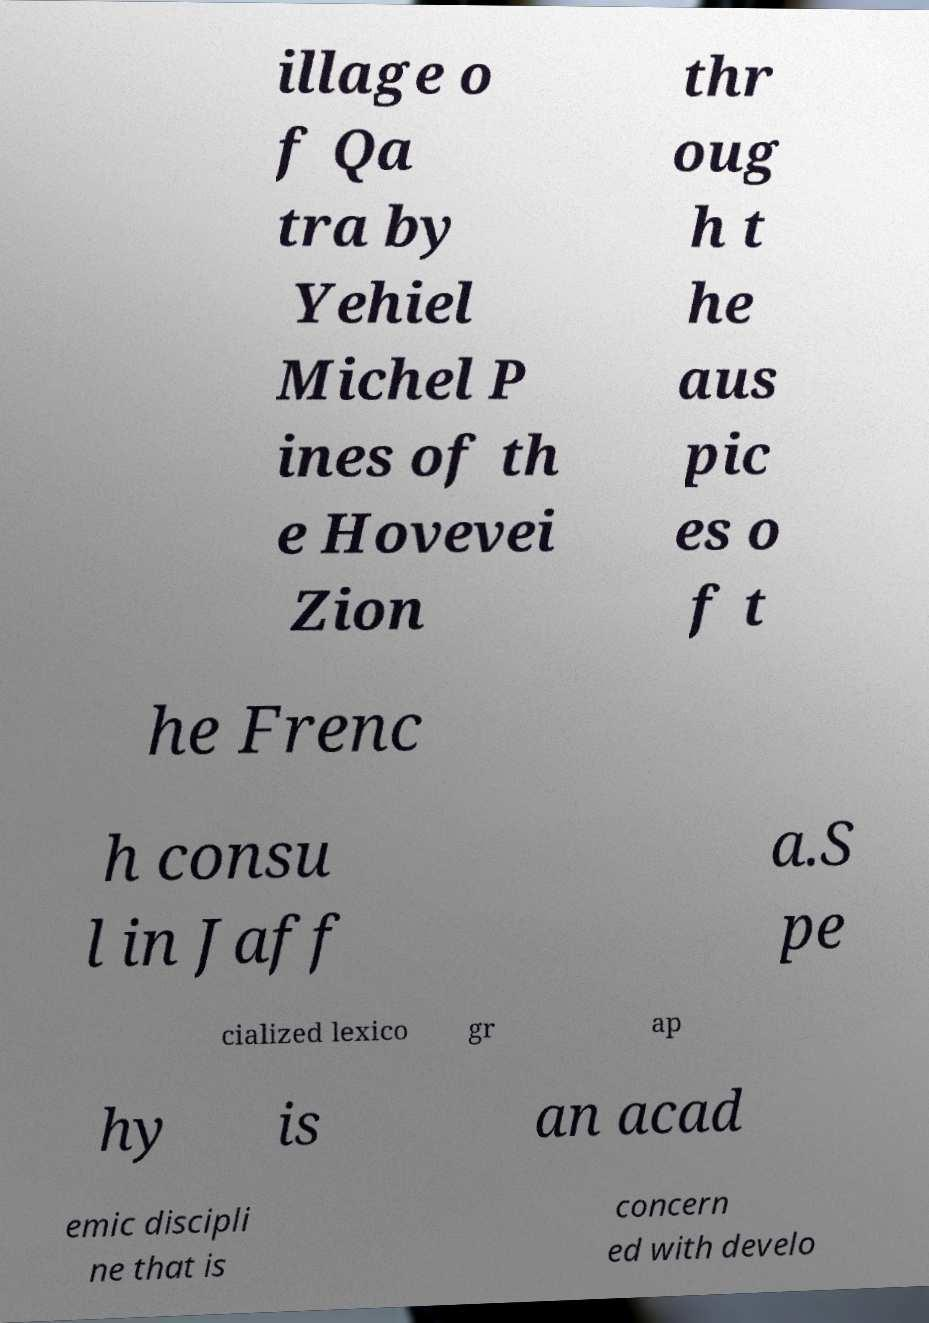What messages or text are displayed in this image? I need them in a readable, typed format. illage o f Qa tra by Yehiel Michel P ines of th e Hovevei Zion thr oug h t he aus pic es o f t he Frenc h consu l in Jaff a.S pe cialized lexico gr ap hy is an acad emic discipli ne that is concern ed with develo 